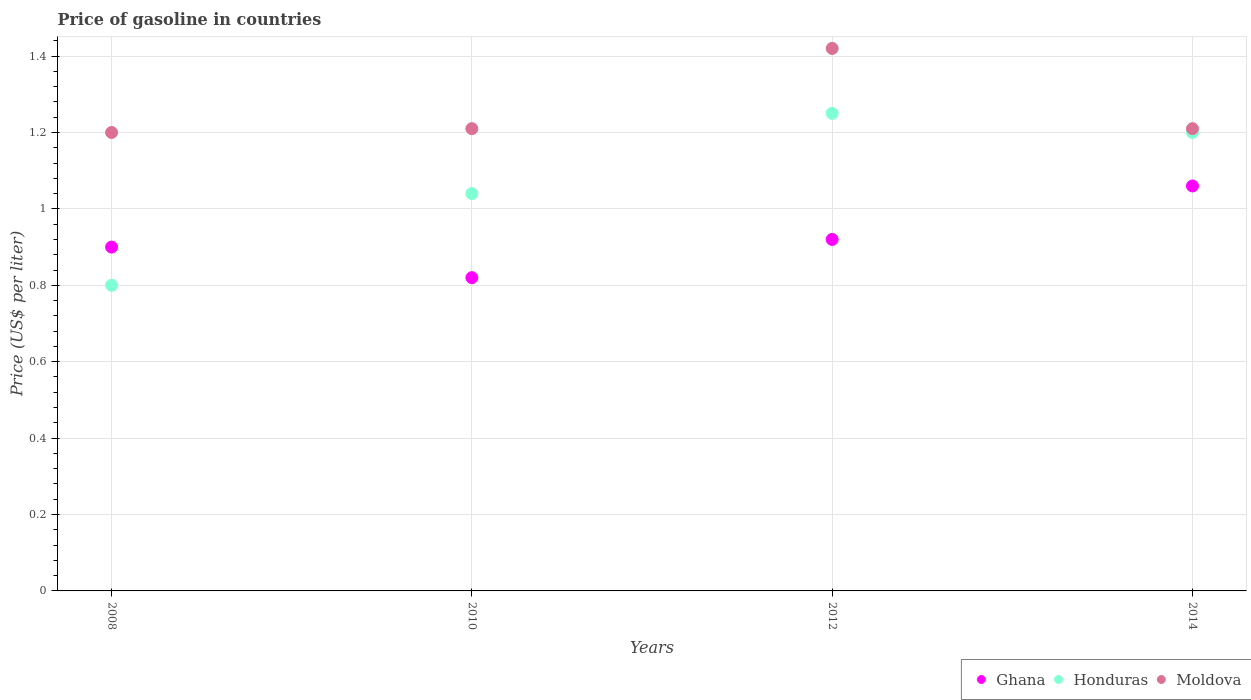Is the number of dotlines equal to the number of legend labels?
Offer a very short reply. Yes. Across all years, what is the maximum price of gasoline in Ghana?
Offer a very short reply. 1.06. In which year was the price of gasoline in Moldova maximum?
Ensure brevity in your answer.  2012. In which year was the price of gasoline in Honduras minimum?
Give a very brief answer. 2008. What is the total price of gasoline in Moldova in the graph?
Offer a very short reply. 5.04. What is the difference between the price of gasoline in Moldova in 2010 and that in 2012?
Provide a short and direct response. -0.21. What is the difference between the price of gasoline in Honduras in 2012 and the price of gasoline in Moldova in 2008?
Keep it short and to the point. 0.05. What is the average price of gasoline in Ghana per year?
Provide a succinct answer. 0.93. In the year 2012, what is the difference between the price of gasoline in Honduras and price of gasoline in Ghana?
Keep it short and to the point. 0.33. What is the ratio of the price of gasoline in Moldova in 2010 to that in 2014?
Your answer should be very brief. 1. Is the price of gasoline in Honduras in 2008 less than that in 2014?
Your answer should be compact. Yes. What is the difference between the highest and the second highest price of gasoline in Moldova?
Give a very brief answer. 0.21. What is the difference between the highest and the lowest price of gasoline in Moldova?
Your answer should be very brief. 0.22. Is it the case that in every year, the sum of the price of gasoline in Moldova and price of gasoline in Honduras  is greater than the price of gasoline in Ghana?
Provide a short and direct response. Yes. Does the price of gasoline in Ghana monotonically increase over the years?
Provide a short and direct response. No. How many dotlines are there?
Offer a terse response. 3. How many years are there in the graph?
Give a very brief answer. 4. What is the difference between two consecutive major ticks on the Y-axis?
Your response must be concise. 0.2. How many legend labels are there?
Provide a succinct answer. 3. What is the title of the graph?
Make the answer very short. Price of gasoline in countries. Does "Kosovo" appear as one of the legend labels in the graph?
Keep it short and to the point. No. What is the label or title of the Y-axis?
Provide a short and direct response. Price (US$ per liter). What is the Price (US$ per liter) of Moldova in 2008?
Your response must be concise. 1.2. What is the Price (US$ per liter) in Ghana in 2010?
Keep it short and to the point. 0.82. What is the Price (US$ per liter) in Moldova in 2010?
Offer a very short reply. 1.21. What is the Price (US$ per liter) in Moldova in 2012?
Make the answer very short. 1.42. What is the Price (US$ per liter) of Ghana in 2014?
Provide a succinct answer. 1.06. What is the Price (US$ per liter) in Moldova in 2014?
Make the answer very short. 1.21. Across all years, what is the maximum Price (US$ per liter) of Ghana?
Provide a short and direct response. 1.06. Across all years, what is the maximum Price (US$ per liter) of Honduras?
Your response must be concise. 1.25. Across all years, what is the maximum Price (US$ per liter) in Moldova?
Offer a very short reply. 1.42. Across all years, what is the minimum Price (US$ per liter) of Ghana?
Offer a terse response. 0.82. Across all years, what is the minimum Price (US$ per liter) in Honduras?
Your answer should be very brief. 0.8. What is the total Price (US$ per liter) in Ghana in the graph?
Provide a succinct answer. 3.7. What is the total Price (US$ per liter) in Honduras in the graph?
Your answer should be compact. 4.29. What is the total Price (US$ per liter) in Moldova in the graph?
Offer a very short reply. 5.04. What is the difference between the Price (US$ per liter) of Honduras in 2008 and that in 2010?
Make the answer very short. -0.24. What is the difference between the Price (US$ per liter) of Moldova in 2008 and that in 2010?
Offer a terse response. -0.01. What is the difference between the Price (US$ per liter) in Ghana in 2008 and that in 2012?
Ensure brevity in your answer.  -0.02. What is the difference between the Price (US$ per liter) in Honduras in 2008 and that in 2012?
Offer a very short reply. -0.45. What is the difference between the Price (US$ per liter) in Moldova in 2008 and that in 2012?
Keep it short and to the point. -0.22. What is the difference between the Price (US$ per liter) of Ghana in 2008 and that in 2014?
Your response must be concise. -0.16. What is the difference between the Price (US$ per liter) of Honduras in 2008 and that in 2014?
Ensure brevity in your answer.  -0.4. What is the difference between the Price (US$ per liter) of Moldova in 2008 and that in 2014?
Give a very brief answer. -0.01. What is the difference between the Price (US$ per liter) of Ghana in 2010 and that in 2012?
Offer a very short reply. -0.1. What is the difference between the Price (US$ per liter) of Honduras in 2010 and that in 2012?
Your answer should be very brief. -0.21. What is the difference between the Price (US$ per liter) of Moldova in 2010 and that in 2012?
Give a very brief answer. -0.21. What is the difference between the Price (US$ per liter) in Ghana in 2010 and that in 2014?
Offer a terse response. -0.24. What is the difference between the Price (US$ per liter) of Honduras in 2010 and that in 2014?
Your response must be concise. -0.16. What is the difference between the Price (US$ per liter) in Ghana in 2012 and that in 2014?
Make the answer very short. -0.14. What is the difference between the Price (US$ per liter) of Honduras in 2012 and that in 2014?
Your response must be concise. 0.05. What is the difference between the Price (US$ per liter) of Moldova in 2012 and that in 2014?
Provide a short and direct response. 0.21. What is the difference between the Price (US$ per liter) of Ghana in 2008 and the Price (US$ per liter) of Honduras in 2010?
Give a very brief answer. -0.14. What is the difference between the Price (US$ per liter) of Ghana in 2008 and the Price (US$ per liter) of Moldova in 2010?
Provide a succinct answer. -0.31. What is the difference between the Price (US$ per liter) in Honduras in 2008 and the Price (US$ per liter) in Moldova in 2010?
Your answer should be very brief. -0.41. What is the difference between the Price (US$ per liter) of Ghana in 2008 and the Price (US$ per liter) of Honduras in 2012?
Your response must be concise. -0.35. What is the difference between the Price (US$ per liter) of Ghana in 2008 and the Price (US$ per liter) of Moldova in 2012?
Your answer should be compact. -0.52. What is the difference between the Price (US$ per liter) in Honduras in 2008 and the Price (US$ per liter) in Moldova in 2012?
Provide a succinct answer. -0.62. What is the difference between the Price (US$ per liter) in Ghana in 2008 and the Price (US$ per liter) in Honduras in 2014?
Make the answer very short. -0.3. What is the difference between the Price (US$ per liter) in Ghana in 2008 and the Price (US$ per liter) in Moldova in 2014?
Keep it short and to the point. -0.31. What is the difference between the Price (US$ per liter) of Honduras in 2008 and the Price (US$ per liter) of Moldova in 2014?
Make the answer very short. -0.41. What is the difference between the Price (US$ per liter) of Ghana in 2010 and the Price (US$ per liter) of Honduras in 2012?
Offer a very short reply. -0.43. What is the difference between the Price (US$ per liter) in Ghana in 2010 and the Price (US$ per liter) in Moldova in 2012?
Your response must be concise. -0.6. What is the difference between the Price (US$ per liter) in Honduras in 2010 and the Price (US$ per liter) in Moldova in 2012?
Your answer should be very brief. -0.38. What is the difference between the Price (US$ per liter) in Ghana in 2010 and the Price (US$ per liter) in Honduras in 2014?
Your answer should be very brief. -0.38. What is the difference between the Price (US$ per liter) of Ghana in 2010 and the Price (US$ per liter) of Moldova in 2014?
Give a very brief answer. -0.39. What is the difference between the Price (US$ per liter) in Honduras in 2010 and the Price (US$ per liter) in Moldova in 2014?
Provide a succinct answer. -0.17. What is the difference between the Price (US$ per liter) of Ghana in 2012 and the Price (US$ per liter) of Honduras in 2014?
Your answer should be compact. -0.28. What is the difference between the Price (US$ per liter) in Ghana in 2012 and the Price (US$ per liter) in Moldova in 2014?
Ensure brevity in your answer.  -0.29. What is the average Price (US$ per liter) of Ghana per year?
Keep it short and to the point. 0.93. What is the average Price (US$ per liter) of Honduras per year?
Your response must be concise. 1.07. What is the average Price (US$ per liter) of Moldova per year?
Keep it short and to the point. 1.26. In the year 2008, what is the difference between the Price (US$ per liter) in Ghana and Price (US$ per liter) in Honduras?
Provide a succinct answer. 0.1. In the year 2008, what is the difference between the Price (US$ per liter) in Ghana and Price (US$ per liter) in Moldova?
Provide a succinct answer. -0.3. In the year 2008, what is the difference between the Price (US$ per liter) in Honduras and Price (US$ per liter) in Moldova?
Offer a terse response. -0.4. In the year 2010, what is the difference between the Price (US$ per liter) in Ghana and Price (US$ per liter) in Honduras?
Provide a short and direct response. -0.22. In the year 2010, what is the difference between the Price (US$ per liter) of Ghana and Price (US$ per liter) of Moldova?
Make the answer very short. -0.39. In the year 2010, what is the difference between the Price (US$ per liter) of Honduras and Price (US$ per liter) of Moldova?
Offer a terse response. -0.17. In the year 2012, what is the difference between the Price (US$ per liter) in Ghana and Price (US$ per liter) in Honduras?
Your answer should be compact. -0.33. In the year 2012, what is the difference between the Price (US$ per liter) in Honduras and Price (US$ per liter) in Moldova?
Provide a short and direct response. -0.17. In the year 2014, what is the difference between the Price (US$ per liter) in Ghana and Price (US$ per liter) in Honduras?
Your response must be concise. -0.14. In the year 2014, what is the difference between the Price (US$ per liter) in Ghana and Price (US$ per liter) in Moldova?
Your answer should be compact. -0.15. In the year 2014, what is the difference between the Price (US$ per liter) of Honduras and Price (US$ per liter) of Moldova?
Offer a very short reply. -0.01. What is the ratio of the Price (US$ per liter) of Ghana in 2008 to that in 2010?
Your answer should be compact. 1.1. What is the ratio of the Price (US$ per liter) of Honduras in 2008 to that in 2010?
Provide a succinct answer. 0.77. What is the ratio of the Price (US$ per liter) in Ghana in 2008 to that in 2012?
Keep it short and to the point. 0.98. What is the ratio of the Price (US$ per liter) in Honduras in 2008 to that in 2012?
Your answer should be very brief. 0.64. What is the ratio of the Price (US$ per liter) of Moldova in 2008 to that in 2012?
Provide a succinct answer. 0.85. What is the ratio of the Price (US$ per liter) of Ghana in 2008 to that in 2014?
Make the answer very short. 0.85. What is the ratio of the Price (US$ per liter) in Honduras in 2008 to that in 2014?
Make the answer very short. 0.67. What is the ratio of the Price (US$ per liter) of Moldova in 2008 to that in 2014?
Ensure brevity in your answer.  0.99. What is the ratio of the Price (US$ per liter) of Ghana in 2010 to that in 2012?
Make the answer very short. 0.89. What is the ratio of the Price (US$ per liter) of Honduras in 2010 to that in 2012?
Your answer should be very brief. 0.83. What is the ratio of the Price (US$ per liter) of Moldova in 2010 to that in 2012?
Your answer should be compact. 0.85. What is the ratio of the Price (US$ per liter) in Ghana in 2010 to that in 2014?
Provide a short and direct response. 0.77. What is the ratio of the Price (US$ per liter) in Honduras in 2010 to that in 2014?
Offer a terse response. 0.87. What is the ratio of the Price (US$ per liter) in Ghana in 2012 to that in 2014?
Offer a very short reply. 0.87. What is the ratio of the Price (US$ per liter) in Honduras in 2012 to that in 2014?
Provide a succinct answer. 1.04. What is the ratio of the Price (US$ per liter) of Moldova in 2012 to that in 2014?
Your response must be concise. 1.17. What is the difference between the highest and the second highest Price (US$ per liter) of Ghana?
Provide a succinct answer. 0.14. What is the difference between the highest and the second highest Price (US$ per liter) of Honduras?
Provide a short and direct response. 0.05. What is the difference between the highest and the second highest Price (US$ per liter) in Moldova?
Your answer should be very brief. 0.21. What is the difference between the highest and the lowest Price (US$ per liter) in Ghana?
Your answer should be compact. 0.24. What is the difference between the highest and the lowest Price (US$ per liter) in Honduras?
Your response must be concise. 0.45. What is the difference between the highest and the lowest Price (US$ per liter) of Moldova?
Make the answer very short. 0.22. 